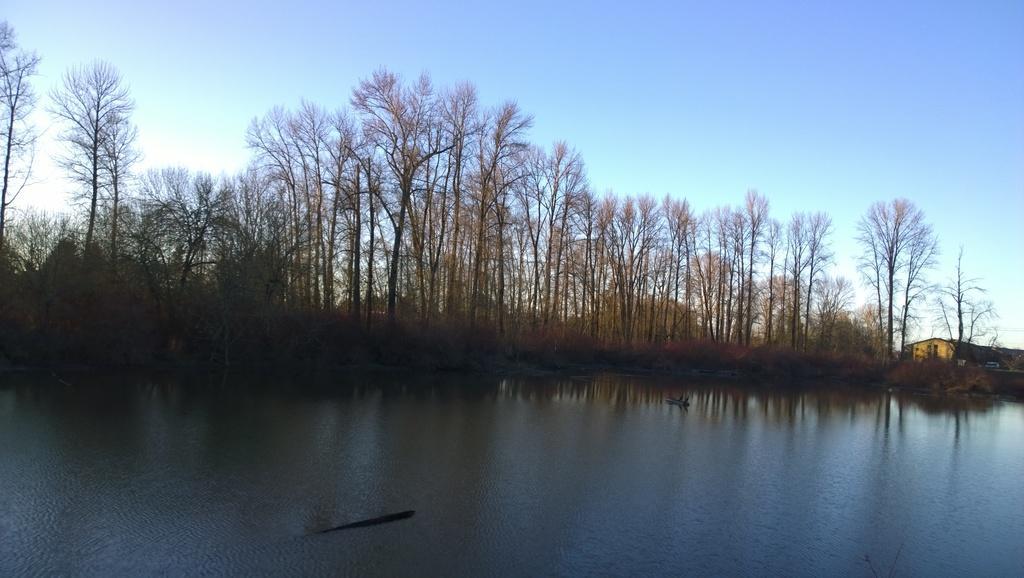How would you summarize this image in a sentence or two? In the image we can see there is a lake and behind there are lot of trees. The sky is clear and there is a building. 